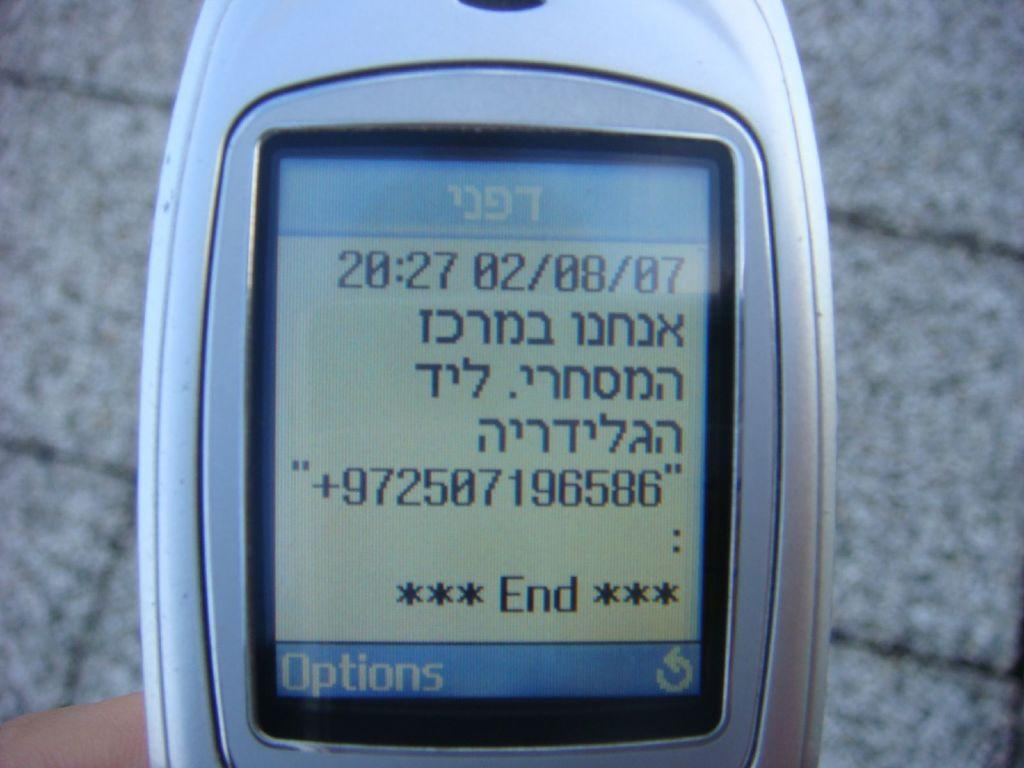What object is located in the foreground of the image? There is a mobile phone in the foreground of the image. What can be seen on the mobile phone's screen? There is text visible on the mobile phone. What type of surface is visible in the background of the image? There is a floor visible in the background of the image. What type of feeling can be seen on the dolls in the image? There are no dolls present in the image; it only features a mobile phone with text on its screen and a floor in the background. 